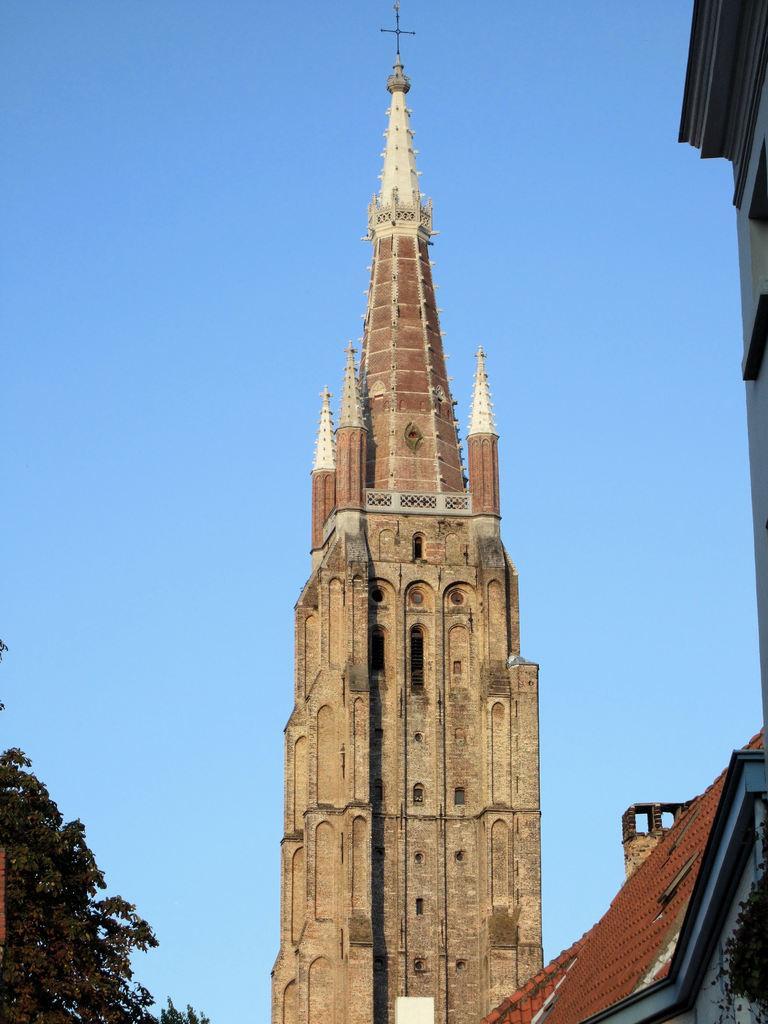Could you give a brief overview of what you see in this image? In the center of the image there is a church. On the right side of the image there are buildings. On the left side of the image there is a tree. In the background of the image there is sky. 